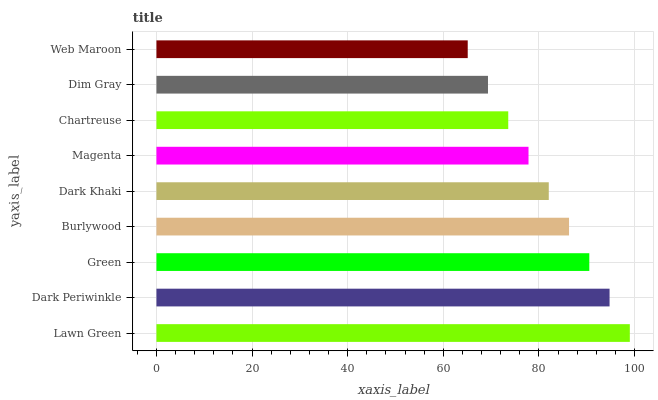Is Web Maroon the minimum?
Answer yes or no. Yes. Is Lawn Green the maximum?
Answer yes or no. Yes. Is Dark Periwinkle the minimum?
Answer yes or no. No. Is Dark Periwinkle the maximum?
Answer yes or no. No. Is Lawn Green greater than Dark Periwinkle?
Answer yes or no. Yes. Is Dark Periwinkle less than Lawn Green?
Answer yes or no. Yes. Is Dark Periwinkle greater than Lawn Green?
Answer yes or no. No. Is Lawn Green less than Dark Periwinkle?
Answer yes or no. No. Is Dark Khaki the high median?
Answer yes or no. Yes. Is Dark Khaki the low median?
Answer yes or no. Yes. Is Dark Periwinkle the high median?
Answer yes or no. No. Is Green the low median?
Answer yes or no. No. 